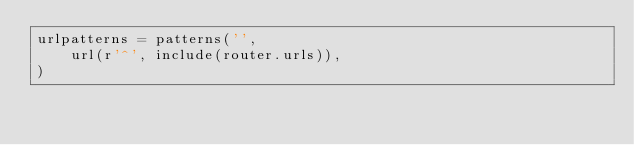Convert code to text. <code><loc_0><loc_0><loc_500><loc_500><_Python_>urlpatterns = patterns('',
    url(r'^', include(router.urls)),
)
</code> 